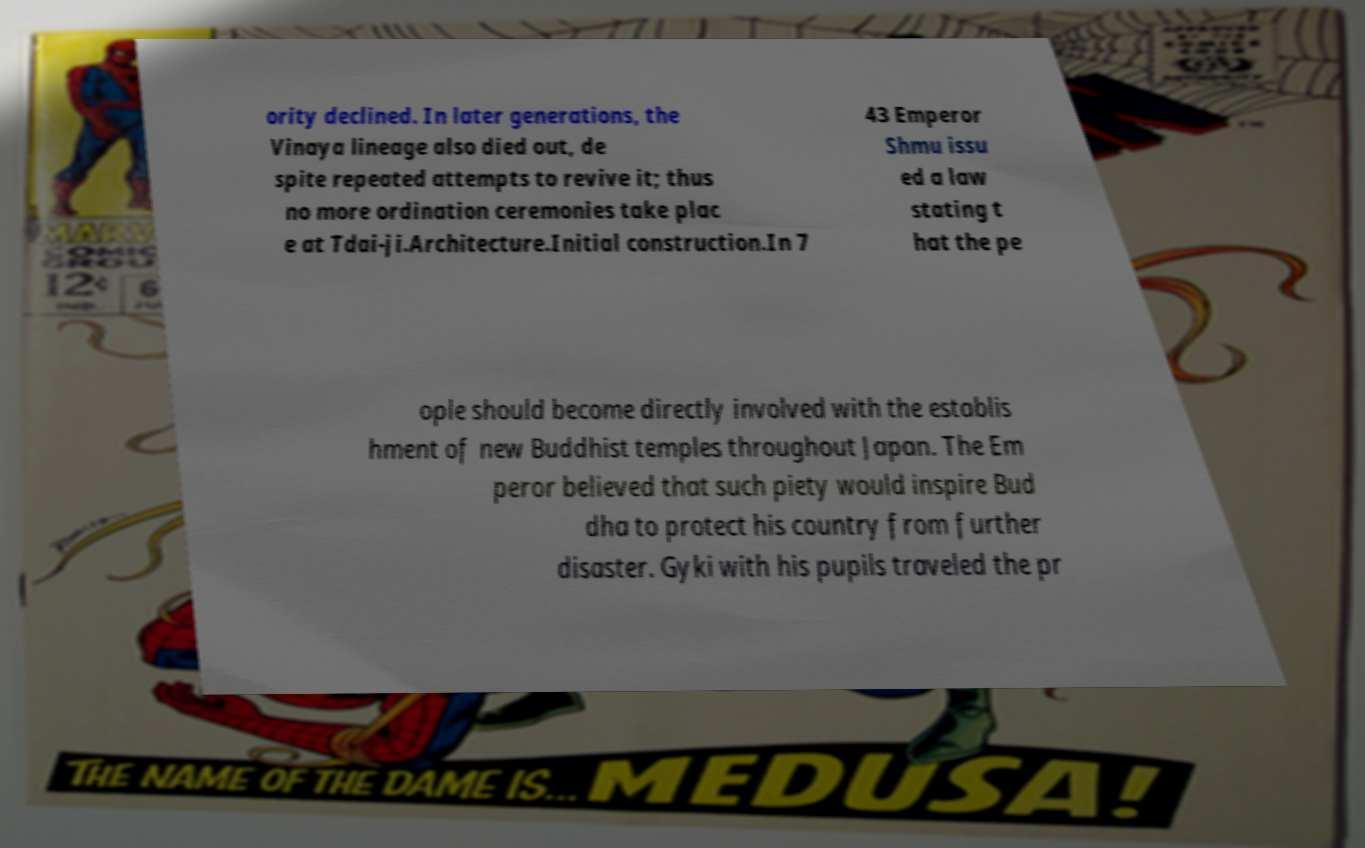Can you read and provide the text displayed in the image?This photo seems to have some interesting text. Can you extract and type it out for me? ority declined. In later generations, the Vinaya lineage also died out, de spite repeated attempts to revive it; thus no more ordination ceremonies take plac e at Tdai-ji.Architecture.Initial construction.In 7 43 Emperor Shmu issu ed a law stating t hat the pe ople should become directly involved with the establis hment of new Buddhist temples throughout Japan. The Em peror believed that such piety would inspire Bud dha to protect his country from further disaster. Gyki with his pupils traveled the pr 